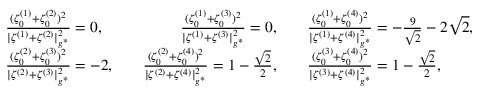Convert formula to latex. <formula><loc_0><loc_0><loc_500><loc_500>\begin{array} { r l r l } & { \frac { ( \zeta _ { 0 } ^ { ( 1 ) } + \zeta _ { 0 } ^ { ( 2 ) } ) ^ { 2 } } { | \zeta ^ { ( 1 ) } + \zeta ^ { ( 2 ) } | _ { g ^ { * } } ^ { 2 } } = 0 , \quad } & { \frac { ( \zeta _ { 0 } ^ { ( 1 ) } + \zeta _ { 0 } ^ { ( 3 ) } ) ^ { 2 } } { | \zeta ^ { ( 1 ) } + \zeta ^ { ( 3 ) } | _ { g ^ { * } } ^ { 2 } } = 0 , \quad } & { \frac { ( \zeta _ { 0 } ^ { ( 1 ) } + \zeta _ { 0 } ^ { ( 4 ) } ) ^ { 2 } } { | \zeta ^ { ( 1 ) } + \zeta ^ { ( 4 ) } | _ { g ^ { * } } ^ { 2 } } = - \frac { 9 } { \sqrt { 2 } } - 2 \sqrt { 2 } , } \\ & { \frac { ( \zeta _ { 0 } ^ { ( 2 ) } + \zeta _ { 0 } ^ { ( 3 ) } ) ^ { 2 } } { | \zeta ^ { ( 2 ) } + \zeta ^ { ( 3 ) } | _ { g ^ { * } } ^ { 2 } } = - 2 , \quad } & { \frac { ( \zeta _ { 0 } ^ { ( 2 ) } + \zeta _ { 0 } ^ { ( 4 ) } ) ^ { 2 } } { | \zeta ^ { ( 2 ) } + \zeta ^ { ( 4 ) } | _ { g ^ { * } } ^ { 2 } } = 1 - \frac { \sqrt { 2 } } { 2 } , \quad } & { \frac { ( \zeta _ { 0 } ^ { ( 3 ) } + \zeta _ { 0 } ^ { ( 4 ) } ) ^ { 2 } } { | \zeta ^ { ( 3 ) } + \zeta ^ { ( 4 ) } | _ { g ^ { * } } ^ { 2 } } = 1 - \frac { \sqrt { 2 } } { 2 } , } \end{array}</formula> 